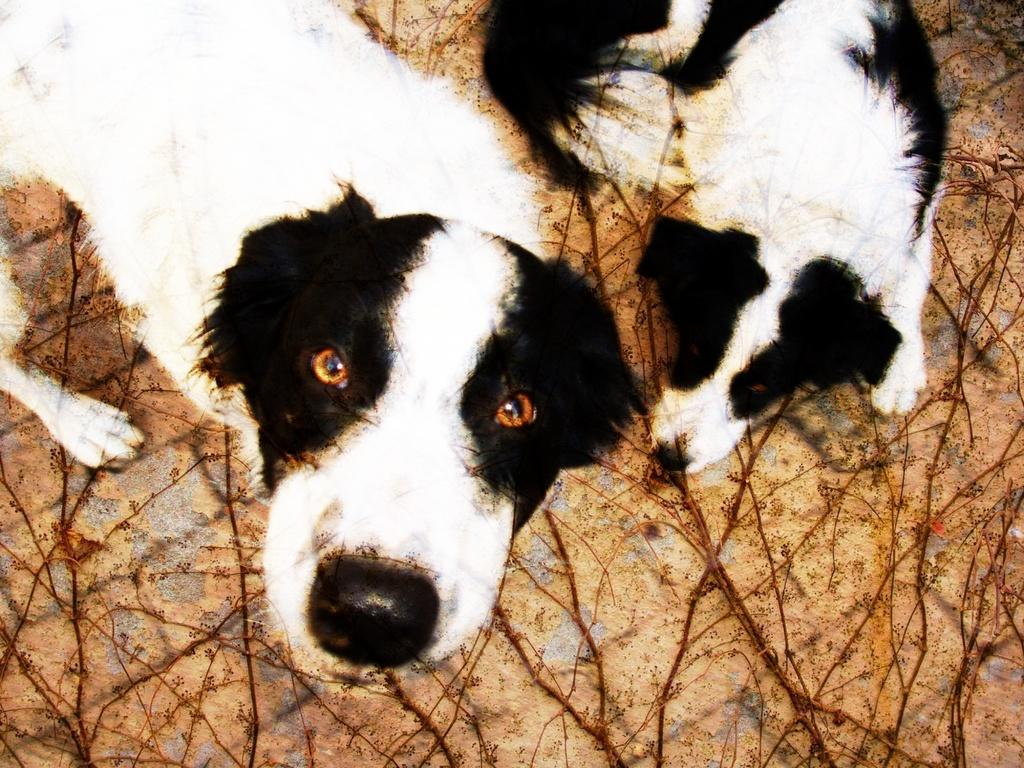How many dogs are present in the image? There are two dogs in the image. What can be found on the ground in the image? There are branches on the ground in the image. Can you touch the frog in the image? There is no frog present in the image, so it cannot be touched. 